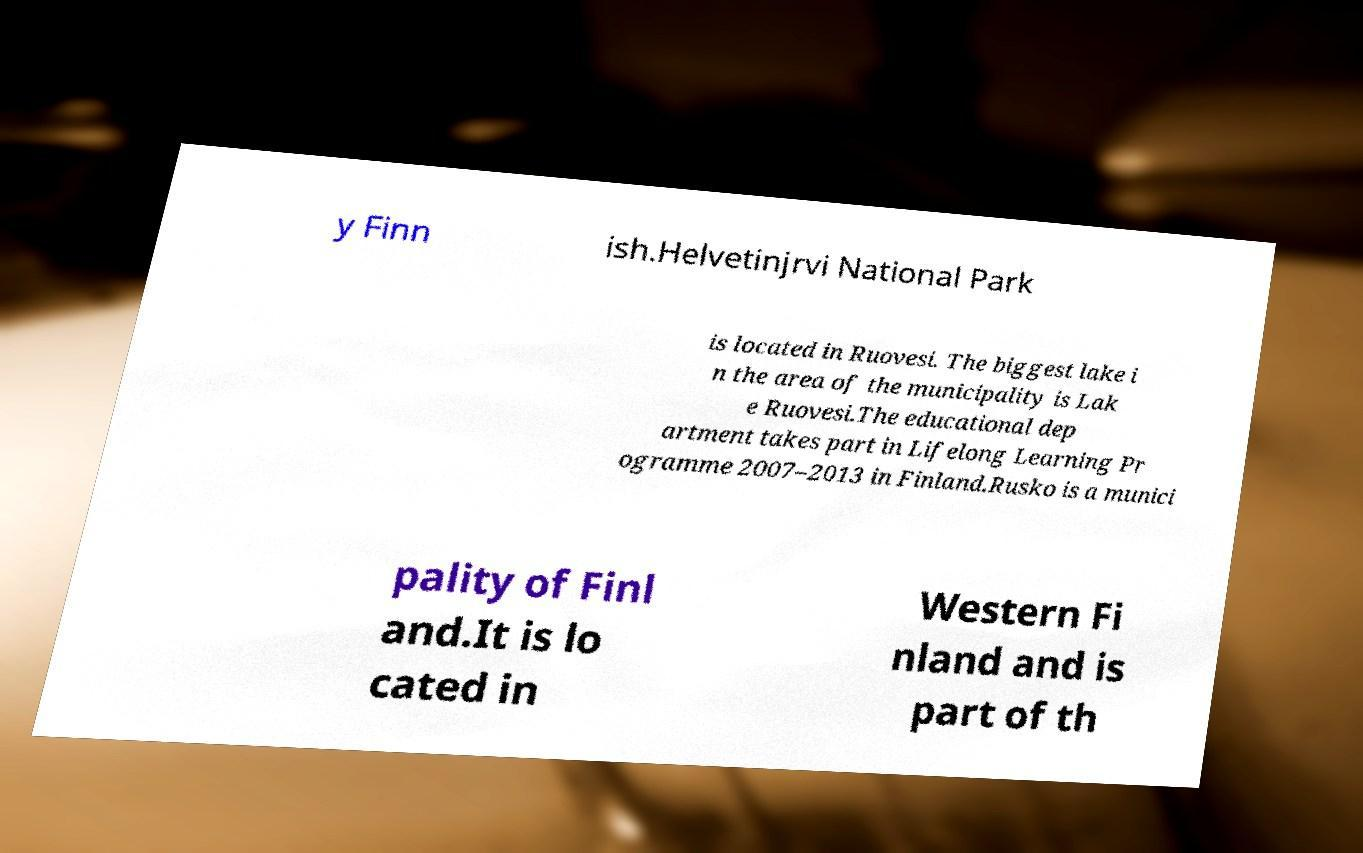Could you extract and type out the text from this image? y Finn ish.Helvetinjrvi National Park is located in Ruovesi. The biggest lake i n the area of the municipality is Lak e Ruovesi.The educational dep artment takes part in Lifelong Learning Pr ogramme 2007–2013 in Finland.Rusko is a munici pality of Finl and.It is lo cated in Western Fi nland and is part of th 